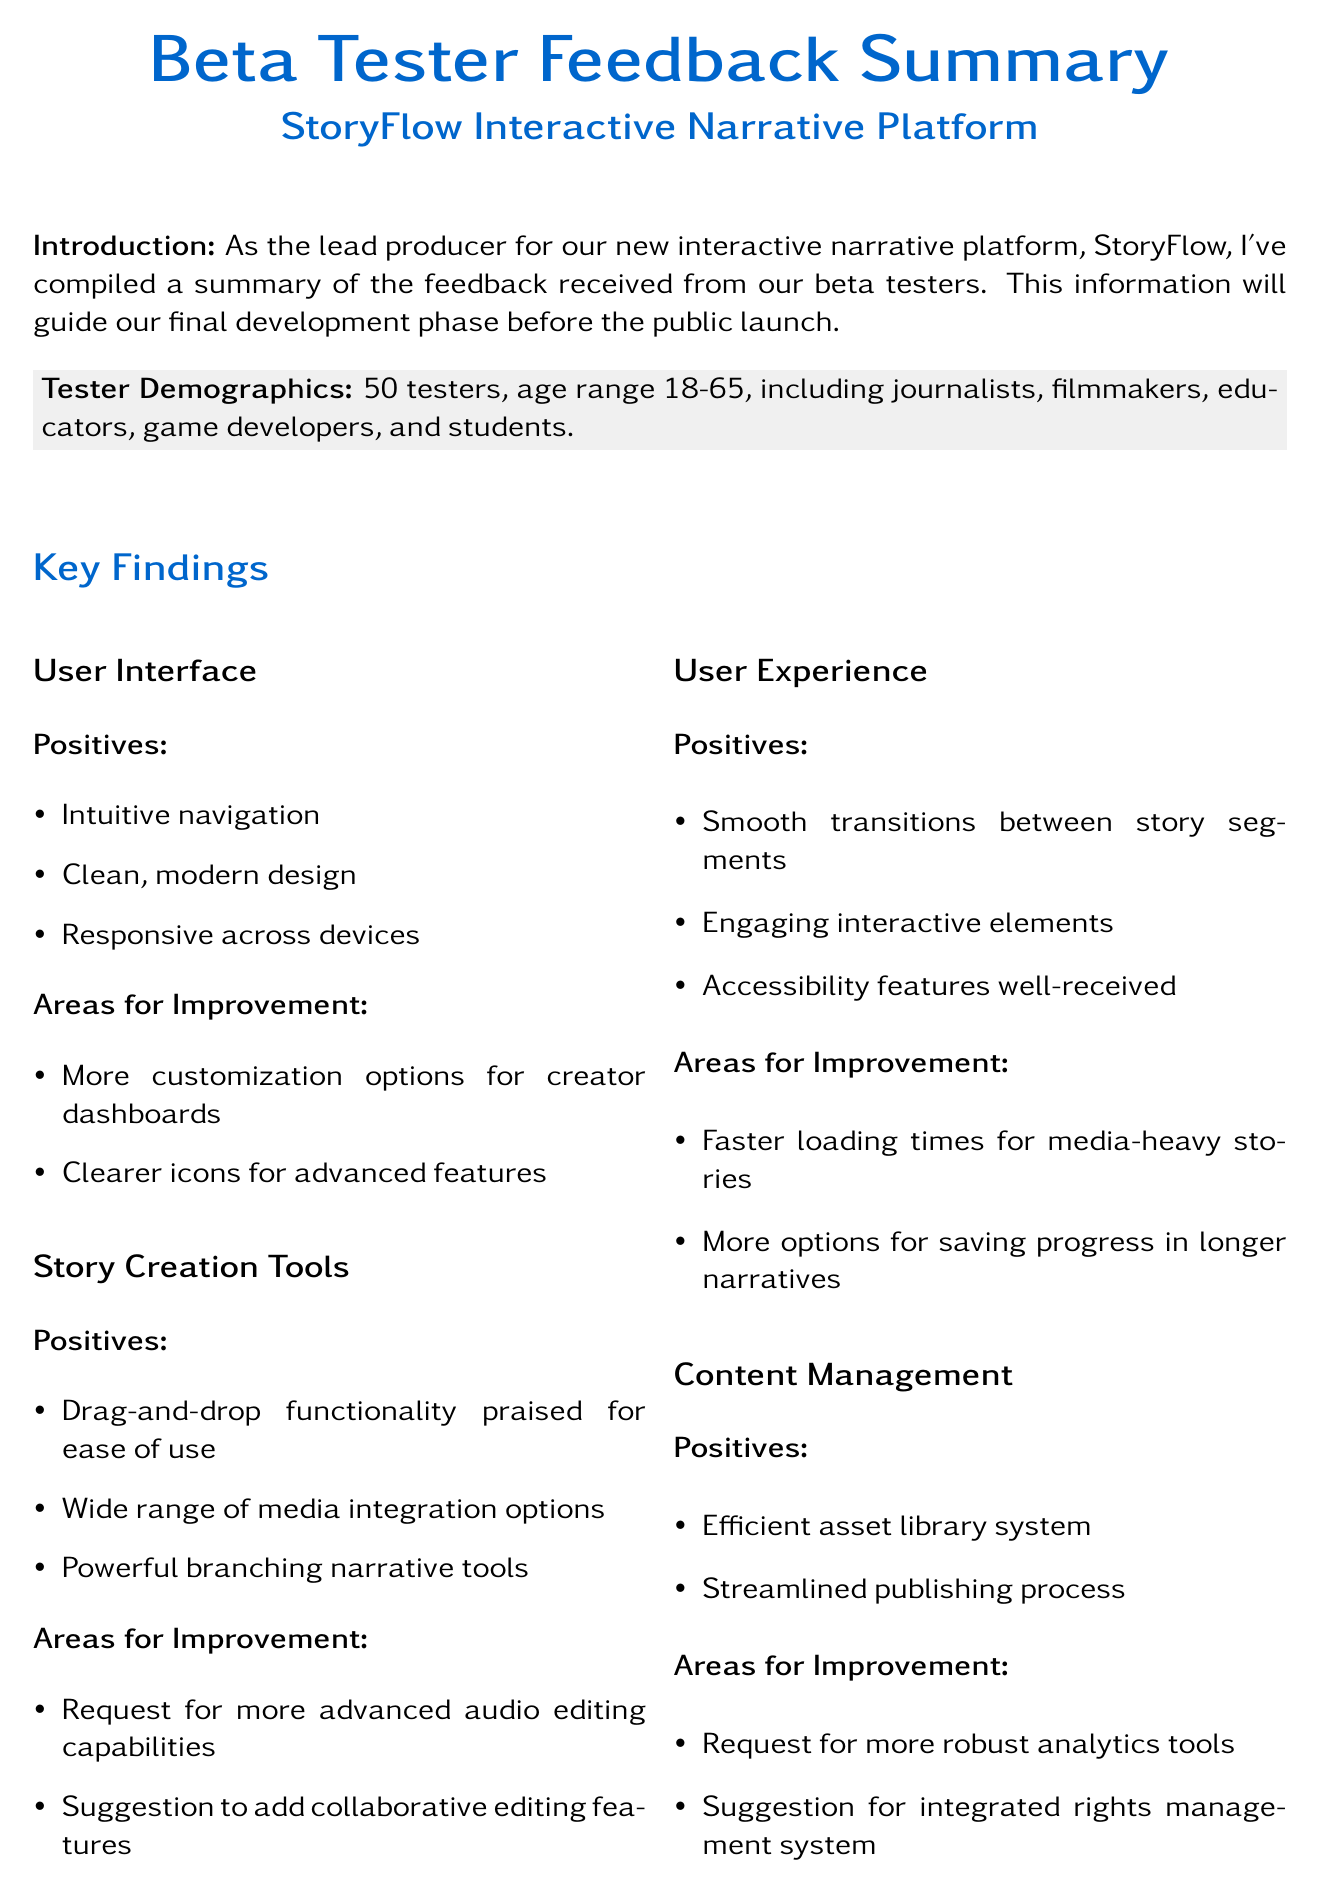What is the total number of beta testers? The total number of beta testers is specified in the demographics section of the memo.
Answer: 50 What is one positive aspect of the User Interface? The document lists positive feedback received from beta testers regarding the User Interface.
Answer: Intuitive navigation What is one area for improvement in Story Creation Tools? The key findings section mentions areas for improvement in Story Creation Tools.
Answer: More advanced audio editing capabilities Who is a documentary filmmaker that provided a testimonial? The user testimonials section includes names and roles of individuals who provided feedback.
Answer: Sarah Chen What do testers think about the loading times for media-heavy stories? The User Experience section indicates areas for improvement that testers identified.
Answer: Faster loading times What is one strength of StoryFlow compared to Eko? The comparison to competitors section outlines strengths and weaknesses of the platform.
Answer: More intuitive What is one next step mentioned in the memo? The next steps section lists actions to be taken based on feedback from beta testers.
Answer: Address UI improvement suggestions in next sprint What is the age range of the beta testers? The demographics section provides the age range of the testers.
Answer: 18-65 What feedback did Marcus Okoye give? The user testimonials section includes quotes from various testers, including Marcus Okoye.
Answer: Powerful tool for teaching modern, interactive journalism techniques 